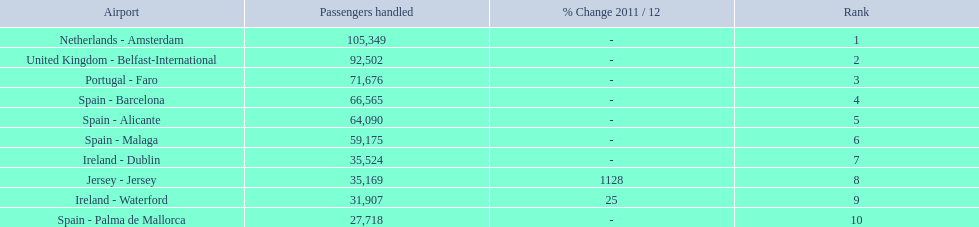What is the highest number of passengers handled? 105,349. What is the destination of the passengers leaving the area that handles 105,349 travellers? Netherlands - Amsterdam. 